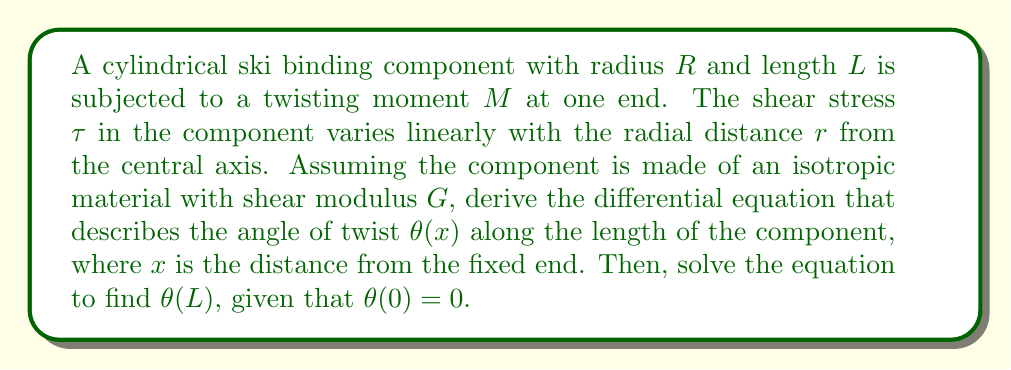Solve this math problem. 1) The shear stress $\tau$ in a circular cross-section under torsion is given by:

   $$\tau = \frac{Gr}{R}\frac{d\theta}{dx}$$

2) The torque $T$ at any cross-section is constant and equal to the applied moment $M$:

   $$T = M = \int_A r\tau dA$$

   where $A$ is the cross-sectional area.

3) Substituting the expression for $\tau$ into the torque equation:

   $$M = \int_0^R \int_0^{2\pi} r \cdot \frac{Gr}{R}\frac{d\theta}{dx} \cdot r d\phi dr$$

4) Evaluating the integral:

   $$M = \frac{G}{R}\frac{d\theta}{dx} \int_0^R \int_0^{2\pi} r^3 d\phi dr = \frac{G\pi R^4}{2}\frac{d\theta}{dx}$$

5) Rearranging to form the differential equation:

   $$\frac{d\theta}{dx} = \frac{2M}{G\pi R^4}$$

6) This is a first-order linear differential equation with constant coefficients. The general solution is:

   $$\theta(x) = \frac{2M}{G\pi R^4}x + C$$

7) Apply the boundary condition $\theta(0) = 0$ to find $C = 0$.

8) Therefore, the specific solution is:

   $$\theta(x) = \frac{2M}{G\pi R^4}x$$

9) To find $\theta(L)$, substitute $x = L$:

   $$\theta(L) = \frac{2ML}{G\pi R^4}$$
Answer: $$\theta(L) = \frac{2ML}{G\pi R^4}$$ 